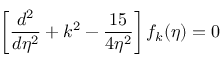Convert formula to latex. <formula><loc_0><loc_0><loc_500><loc_500>\left [ \frac { d ^ { 2 } } { d \eta ^ { 2 } } + k ^ { 2 } - \frac { 1 5 } { 4 \eta ^ { 2 } } \right ] f _ { k } ( \eta ) = 0</formula> 